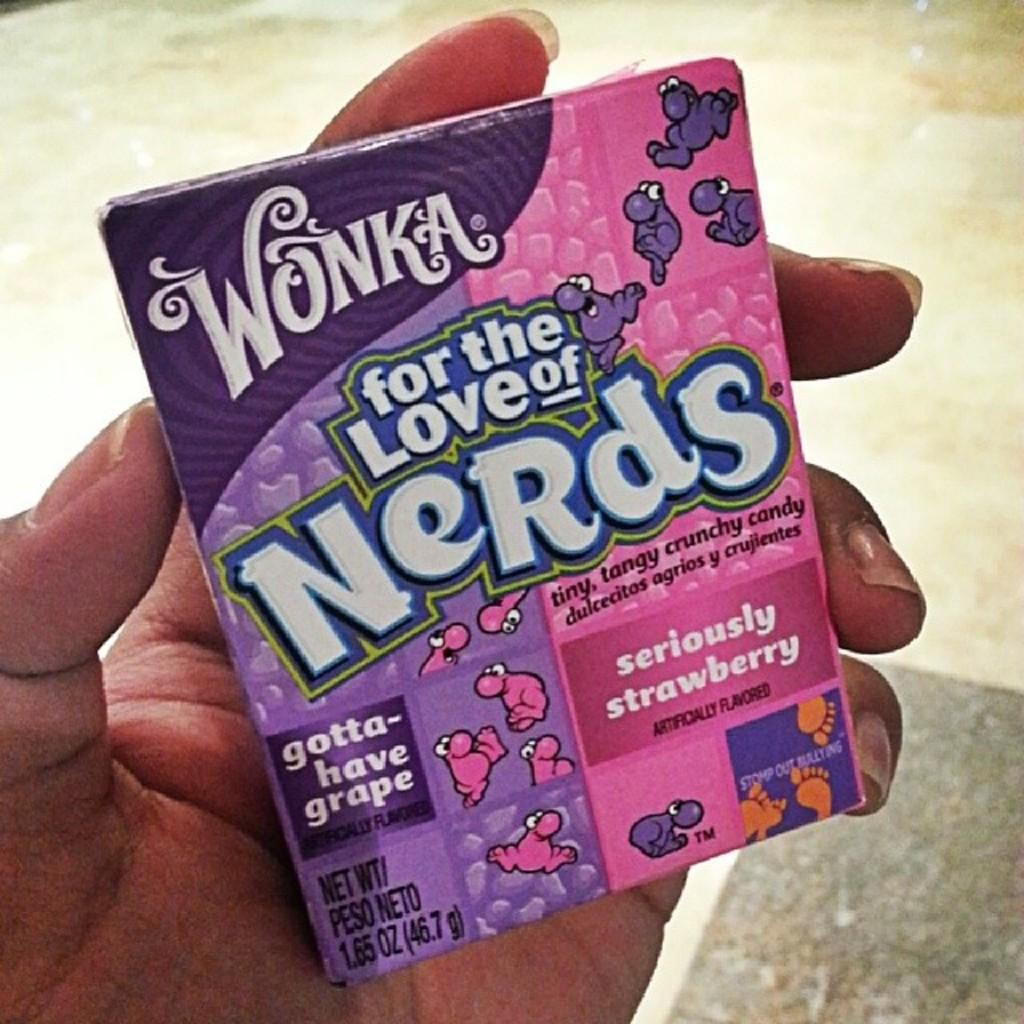What is the main subject of the image? The main subject of the image is a human hand holding an object. What can be seen on the object being held? The object has text on it. What is visible in the background of the image? The background of the image includes the floor. How does the human hand kick the ball in the image? There is no ball present in the image, and the human hand is holding an object with text on it, not kicking anything. 